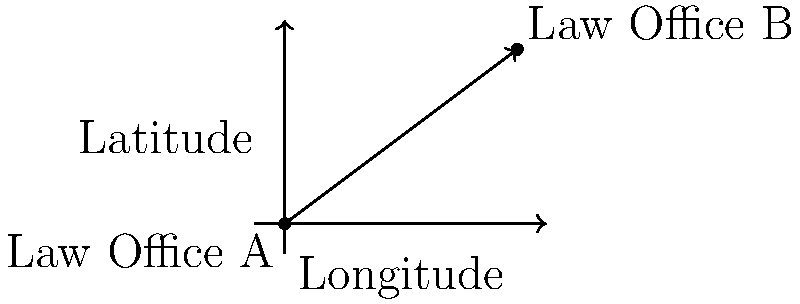As a law student interested in following Otto Petrén's career path, you're researching law office locations. You need to calculate the distance between two law offices using their latitude and longitude coordinates. Law Office A is located at (40.7128° N, 74.0060° W), and Law Office B is at (42.3601° N, 71.0589° W). Given that 1° of latitude is approximately 111 km, calculate the straight-line distance between these two offices using the Haversine formula:

$$ d = 2R \cdot \arcsin\left(\sqrt{\sin^2\left(\frac{\Delta\phi}{2}\right) + \cos\phi_1 \cdot \cos\phi_2 \cdot \sin^2\left(\frac{\Delta\lambda}{2}\right)}\right) $$

Where:
$R$ = Earth's radius (6371 km)
$\phi$ = Latitude in radians
$\lambda$ = Longitude in radians
$\Delta\phi$ = Difference in latitude
$\Delta\lambda$ = Difference in longitude

Round your answer to the nearest kilometer. To solve this problem, let's follow these steps:

1) Convert latitude and longitude to radians:
   $\phi_1 = 40.7128° \cdot \frac{\pi}{180} = 0.7102$ rad
   $\lambda_1 = -74.0060° \cdot \frac{\pi}{180} = -1.2915$ rad
   $\phi_2 = 42.3601° \cdot \frac{\pi}{180} = 0.7392$ rad
   $\lambda_2 = -71.0589° \cdot \frac{\pi}{180} = -1.2404$ rad

2) Calculate differences:
   $\Delta\phi = \phi_2 - \phi_1 = 0.7392 - 0.7102 = 0.0290$ rad
   $\Delta\lambda = \lambda_2 - \lambda_1 = -1.2404 - (-1.2915) = 0.0511$ rad

3) Apply the Haversine formula:
   $d = 2R \cdot \arcsin\left(\sqrt{\sin^2\left(\frac{0.0290}{2}\right) + \cos(0.7102) \cdot \cos(0.7392) \cdot \sin^2\left(\frac{0.0511}{2}\right)}\right)$

4) Calculate:
   $d = 2 \cdot 6371 \cdot \arcsin\left(\sqrt{0.000210 + 0.750934 \cdot 0.000163}\right)$
   $d = 12742 \cdot \arcsin(\sqrt{0.000332})$
   $d = 12742 \cdot 0.0182$
   $d = 231.9044$ km

5) Round to the nearest kilometer:
   $d \approx 232$ km
Answer: 232 km 